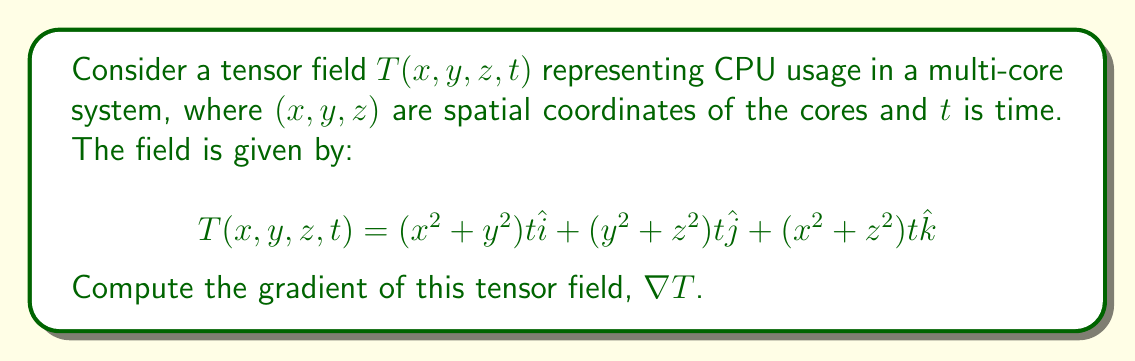What is the answer to this math problem? To compute the gradient of the tensor field, we need to calculate the partial derivatives with respect to each variable $(x, y, z, t)$. The gradient of a vector field in 3D space is given by:

$$\nabla T = \left(\frac{\partial T_x}{\partial x}, \frac{\partial T_x}{\partial y}, \frac{\partial T_x}{\partial z}, \frac{\partial T_x}{\partial t}\right)\hat{i} + \left(\frac{\partial T_y}{\partial x}, \frac{\partial T_y}{\partial y}, \frac{\partial T_y}{\partial z}, \frac{\partial T_y}{\partial t}\right)\hat{j} + \left(\frac{\partial T_z}{\partial x}, \frac{\partial T_z}{\partial y}, \frac{\partial T_z}{\partial z}, \frac{\partial T_z}{\partial t}\right)\hat{k}$$

Let's calculate each component:

1. For $T_x = (x^2 + y^2)t$:
   $\frac{\partial T_x}{\partial x} = 2xt$
   $\frac{\partial T_x}{\partial y} = 2yt$
   $\frac{\partial T_x}{\partial z} = 0$
   $\frac{\partial T_x}{\partial t} = x^2 + y^2$

2. For $T_y = (y^2 + z^2)t$:
   $\frac{\partial T_y}{\partial x} = 0$
   $\frac{\partial T_y}{\partial y} = 2yt$
   $\frac{\partial T_y}{\partial z} = 2zt$
   $\frac{\partial T_y}{\partial t} = y^2 + z^2$

3. For $T_z = (x^2 + z^2)t$:
   $\frac{\partial T_z}{\partial x} = 2xt$
   $\frac{\partial T_z}{\partial y} = 0$
   $\frac{\partial T_z}{\partial z} = 2zt$
   $\frac{\partial T_z}{\partial t} = x^2 + z^2$

Now, we can combine these partial derivatives to form the gradient:

$$\nabla T = (2xt, 2yt, 0, x^2 + y^2)\hat{i} + (0, 2yt, 2zt, y^2 + z^2)\hat{j} + (2xt, 0, 2zt, x^2 + z^2)\hat{k}$$
Answer: $\nabla T = (2xt, 2yt, 0, x^2 + y^2)\hat{i} + (0, 2yt, 2zt, y^2 + z^2)\hat{j} + (2xt, 0, 2zt, x^2 + z^2)\hat{k}$ 